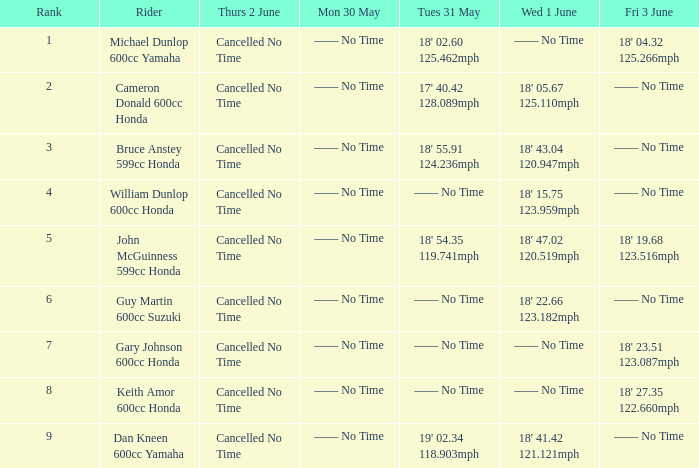What is the number of riders that had a Tues 31 May time of 18' 55.91 124.236mph? 1.0. 